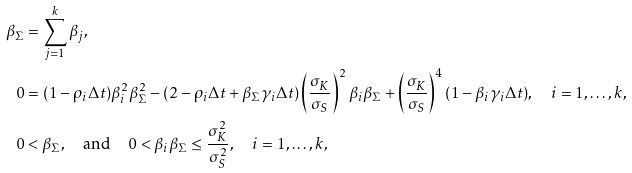<formula> <loc_0><loc_0><loc_500><loc_500>\beta _ { \Sigma } & = \sum _ { j = 1 } ^ { k } \beta _ { j } , \\ 0 & = ( 1 - \rho _ { i } \Delta t ) \beta _ { i } ^ { 2 } \beta _ { \Sigma } ^ { 2 } - ( 2 - \rho _ { i } \Delta t + \beta _ { \Sigma } \gamma _ { i } \Delta t ) \left ( \frac { \sigma _ { K } } { \sigma _ { S } } \right ) ^ { 2 } \beta _ { i } \beta _ { \Sigma } + \left ( \frac { \sigma _ { K } } { \sigma _ { S } } \right ) ^ { 4 } ( 1 - \beta _ { i } \gamma _ { i } \Delta t ) , \quad i = 1 , \dots , k , \\ 0 & < \beta _ { \Sigma } , \quad \text {and} \quad 0 < \beta _ { i } \beta _ { \Sigma } \leq \frac { \sigma _ { K } ^ { 2 } } { \sigma _ { S } ^ { 2 } } , \quad i = 1 , \dots , k ,</formula> 